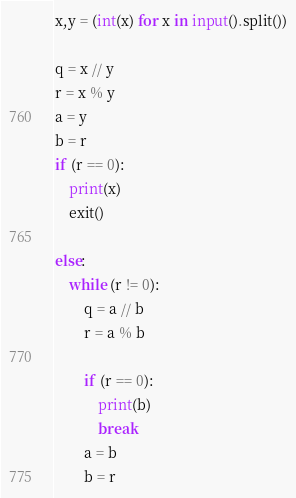Convert code to text. <code><loc_0><loc_0><loc_500><loc_500><_Python_>x,y = (int(x) for x in input().split())

q = x // y
r = x % y
a = y
b = r
if (r == 0):
    print(x)
    exit()

else:
    while (r != 0):
        q = a // b
        r = a % b

        if (r == 0):
            print(b)
            break
        a = b
        b = r

</code> 